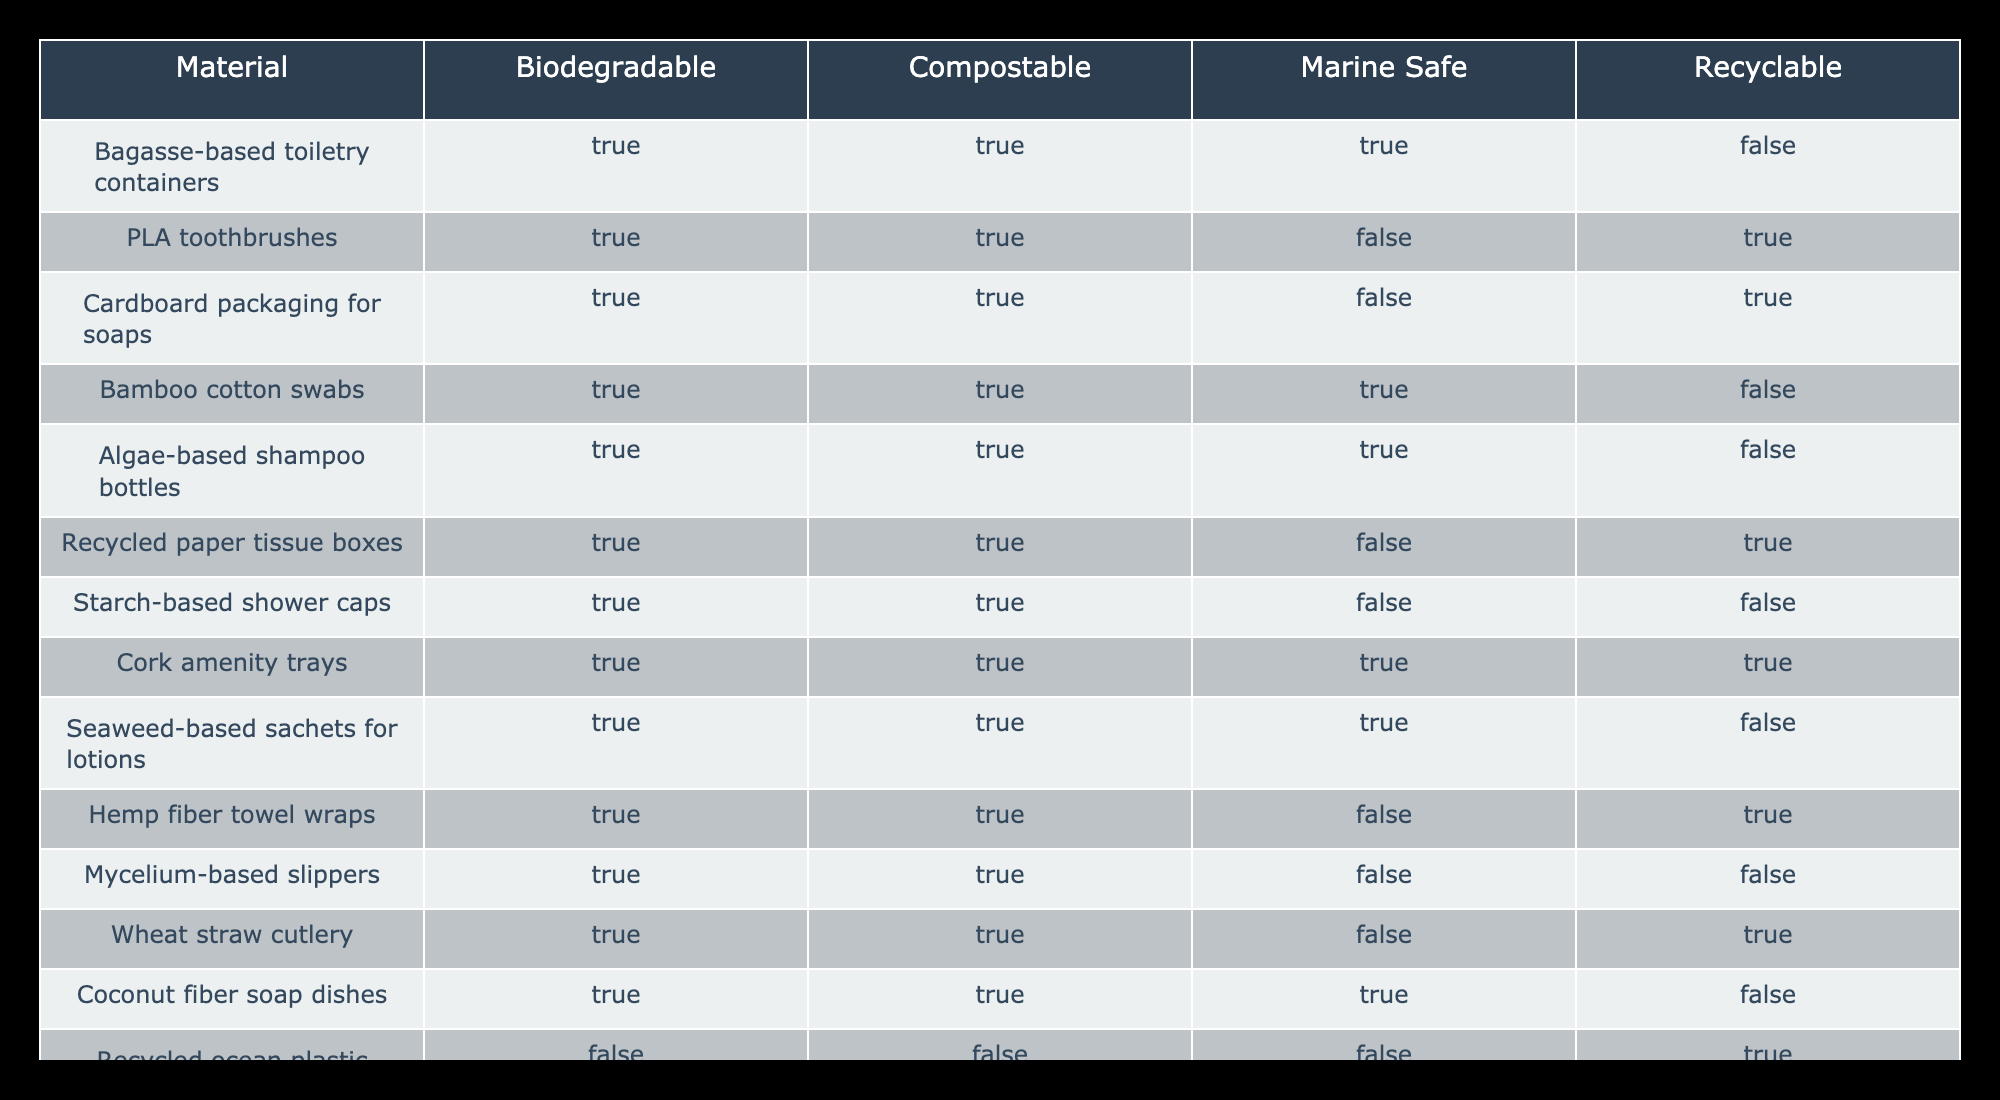What materials are compostable? The table lists the materials along with columns indicating whether they are compostable. Looking at the "Compostable" column, the materials that have "True" are Bagasse-based toiletry containers, PLA toothbrushes, Cardboard packaging for soaps, Bamboo cotton swabs, Algae-based shampoo bottles, Recycled paper tissue boxes, Starch-based shower caps, Cork amenity trays, Seaweed-based sachets for lotions, Hemp fiber towel wraps, Wheat straw cutlery, and Sugarcane-based toothpaste tubes.
Answer: Bagasse-based toiletry containers, PLA toothbrushes, Cardboard packaging for soaps, Bamboo cotton swabs, Algae-based shampoo bottles, Recycled paper tissue boxes, Starch-based shower caps, Cork amenity trays, Seaweed-based sachets for lotions, Hemp fiber towel wraps, Wheat straw cutlery, Sugarcane-based toothpaste tubes How many materials are marine safe? The "Marine Safe" column indicates whether each material is safe for marine environments. By scanning through the column, we find that the materials which are "True" for marine safety are Bamboo cotton swabs, Algae-based shampoo bottles, Cork amenity trays, and Seaweed-based sachets for lotions. Counting these gives us 4 materials.
Answer: 4 Is the recycled ocean plastic amenity bottle biodegradable? To determine if the recycled ocean plastic amenity bottles are biodegradable, we need to check the "Biodegradable" column. The entry for recycled ocean plastic amenity bottles is "False," indicating that this material is not biodegradable.
Answer: No Which materials are both biodegradable and recyclable? We look for materials where both "Biodegradable" and "Recyclable" columns have "True". By checking the table, we find the following materials listed: PLA toothbrushes, Cardboard packaging for soaps, Recycled paper tissue boxes, Cork amenity trays, and Sugarcane-based toothpaste tubes. Counting these yields five materials.
Answer: 5 What percentage of the materials are not recyclable? First, we need to determine the total number of materials listed, which is 15. Next, we identify those that are not recyclable. Looking at the "Recyclable" column, we see that the materials which have "False" are Bagasse-based toiletry containers, Algae-based shampoo bottles, Starch-based shower caps, Mycelium-based slippers, and Coconut fiber soap dishes (5 materials). Therefore, the number of materials that are not recyclable is 5. To calculate the percentage: (5 / 15) * 100 = 33.33%.
Answer: 33.33% Which materials are compostable, marine safe, and recyclable? To answer this question, we will search for materials that have "True" in all three categories: "Compostable," "Marine Safe," and "Recyclable." After reviewing the table, we find that only Cork amenity trays fit this criteria.
Answer: Cork amenity trays 